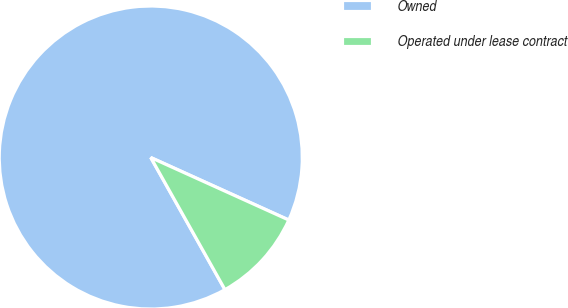Convert chart to OTSL. <chart><loc_0><loc_0><loc_500><loc_500><pie_chart><fcel>Owned<fcel>Operated under lease contract<nl><fcel>89.91%<fcel>10.09%<nl></chart> 